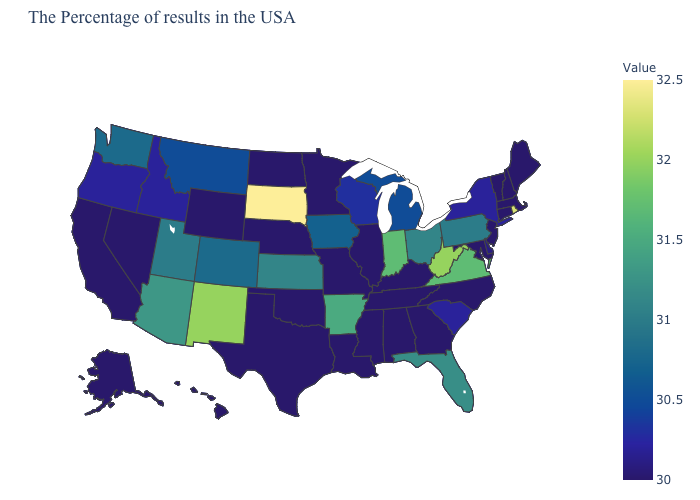Which states have the lowest value in the USA?
Write a very short answer. Maine, Massachusetts, New Hampshire, Vermont, Connecticut, New Jersey, Maryland, North Carolina, Georgia, Kentucky, Alabama, Tennessee, Illinois, Mississippi, Louisiana, Missouri, Minnesota, Nebraska, Oklahoma, Texas, North Dakota, Wyoming, Nevada, California, Alaska, Hawaii. Is the legend a continuous bar?
Answer briefly. Yes. Among the states that border Pennsylvania , does Ohio have the lowest value?
Concise answer only. No. Is the legend a continuous bar?
Write a very short answer. Yes. 